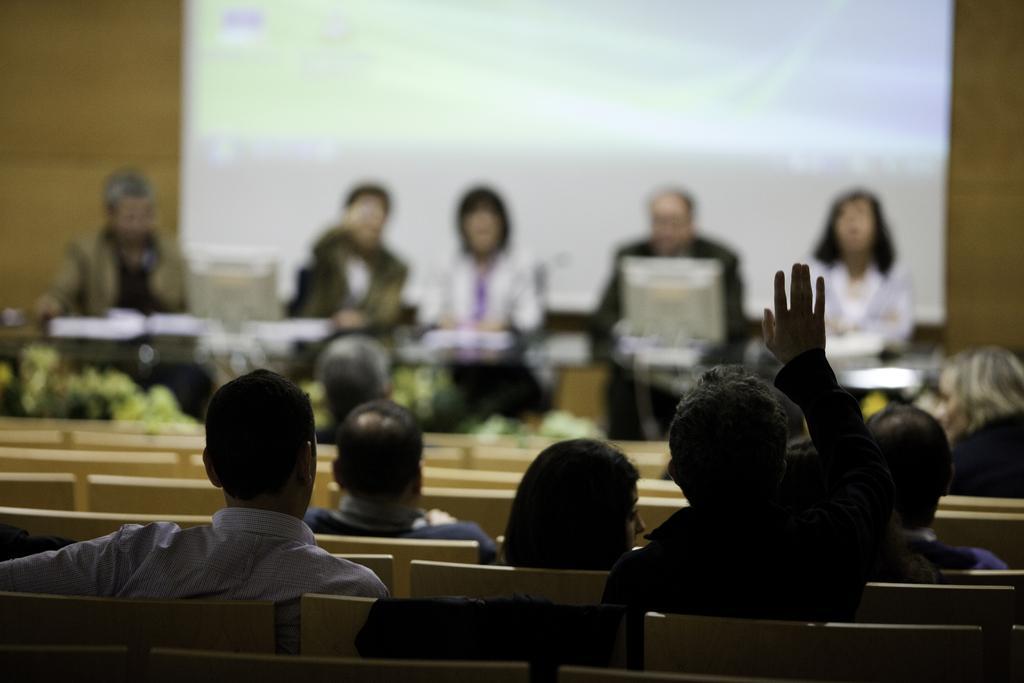Can you describe this image briefly? In this image there are people sitting on the chairs. There are people sitting behind the table having a monitor and few objects. There is a screen attached to the wall. 